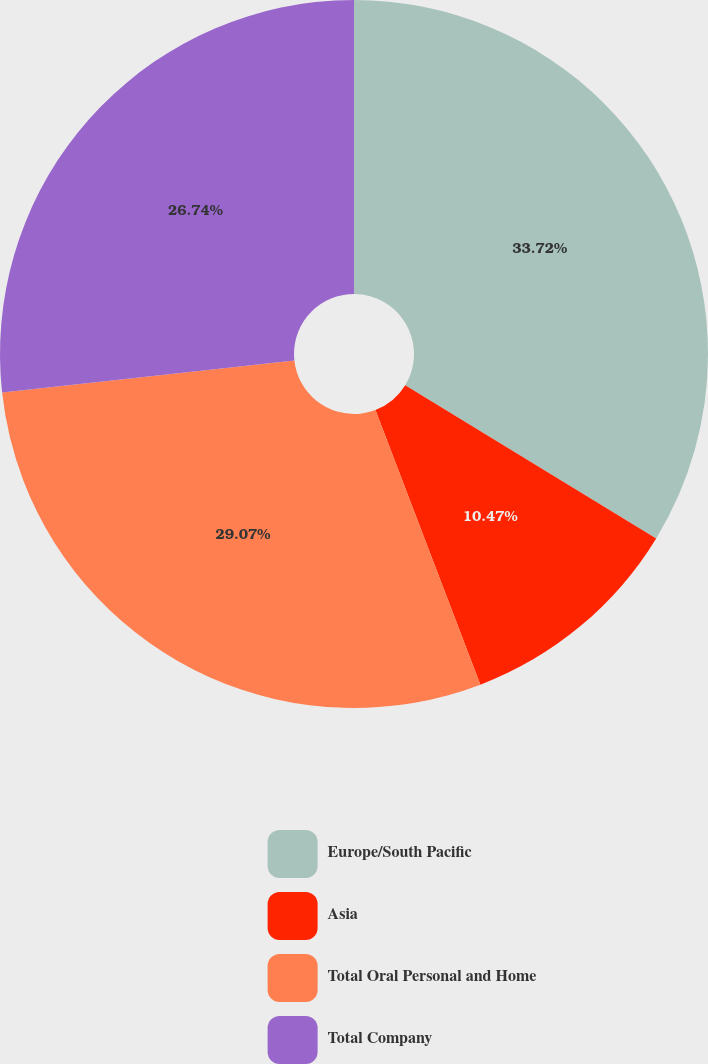Convert chart to OTSL. <chart><loc_0><loc_0><loc_500><loc_500><pie_chart><fcel>Europe/South Pacific<fcel>Asia<fcel>Total Oral Personal and Home<fcel>Total Company<nl><fcel>33.72%<fcel>10.47%<fcel>29.07%<fcel>26.74%<nl></chart> 